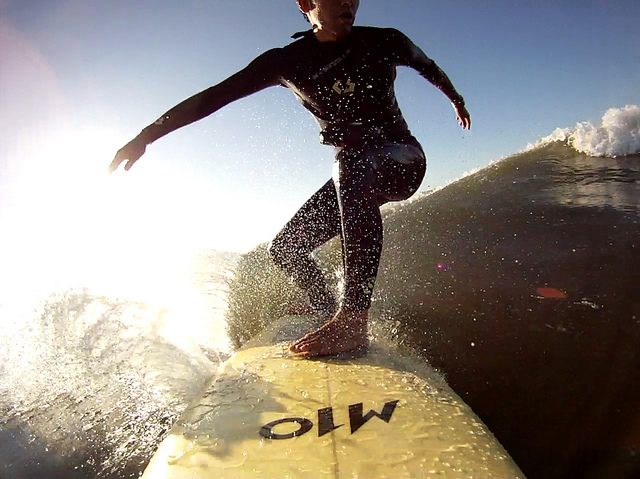Please transcribe the text in this image. LOW 